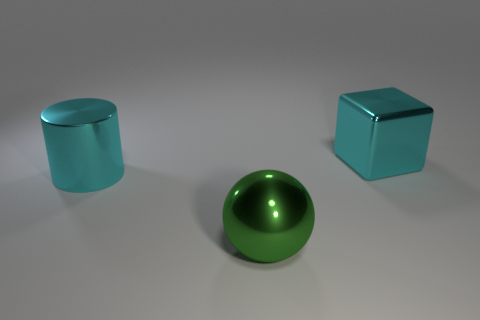Are there more green shiny objects that are behind the green metallic ball than green objects behind the cyan metallic cylinder?
Your response must be concise. No. There is a shiny thing that is the same color as the block; what size is it?
Give a very brief answer. Large. What is the color of the sphere?
Your response must be concise. Green. What is the color of the object that is both behind the big green thing and in front of the large block?
Your response must be concise. Cyan. There is a object on the right side of the green thing that is to the right of the cyan metallic object that is in front of the cyan shiny block; what color is it?
Keep it short and to the point. Cyan. There is a block that is the same size as the ball; what color is it?
Provide a succinct answer. Cyan. There is a cyan thing to the right of the big object in front of the cyan metallic thing to the left of the cyan cube; what shape is it?
Your answer should be compact. Cube. What shape is the large thing that is the same color as the cube?
Your response must be concise. Cylinder. What number of things are either large green things or big shiny spheres that are to the left of the big cube?
Provide a short and direct response. 1. Do the cyan object on the left side of the shiny block and the ball have the same size?
Ensure brevity in your answer.  Yes. 